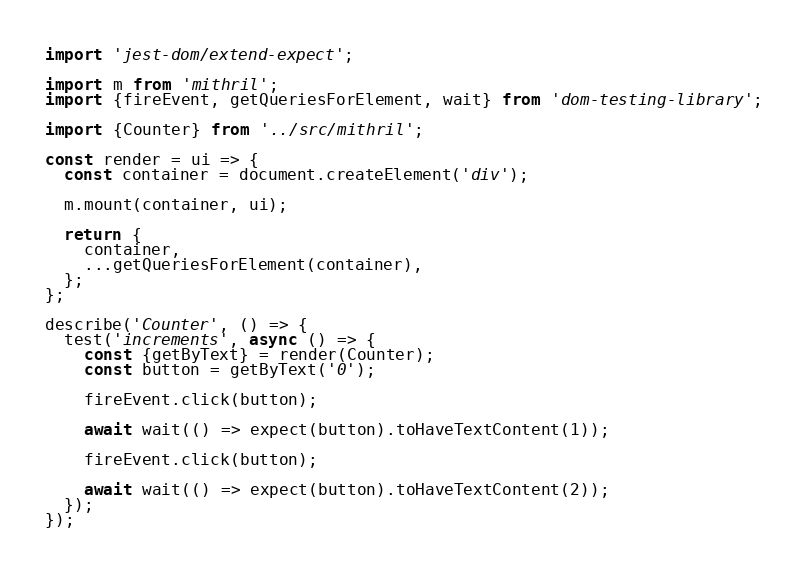Convert code to text. <code><loc_0><loc_0><loc_500><loc_500><_JavaScript_>import 'jest-dom/extend-expect';

import m from 'mithril';
import {fireEvent, getQueriesForElement, wait} from 'dom-testing-library';

import {Counter} from '../src/mithril';

const render = ui => {
  const container = document.createElement('div');

  m.mount(container, ui);

  return {
    container,
    ...getQueriesForElement(container),
  };
};

describe('Counter', () => {
  test('increments', async () => {
    const {getByText} = render(Counter);
    const button = getByText('0');

    fireEvent.click(button);

    await wait(() => expect(button).toHaveTextContent(1));

    fireEvent.click(button);

    await wait(() => expect(button).toHaveTextContent(2));
  });
});
</code> 